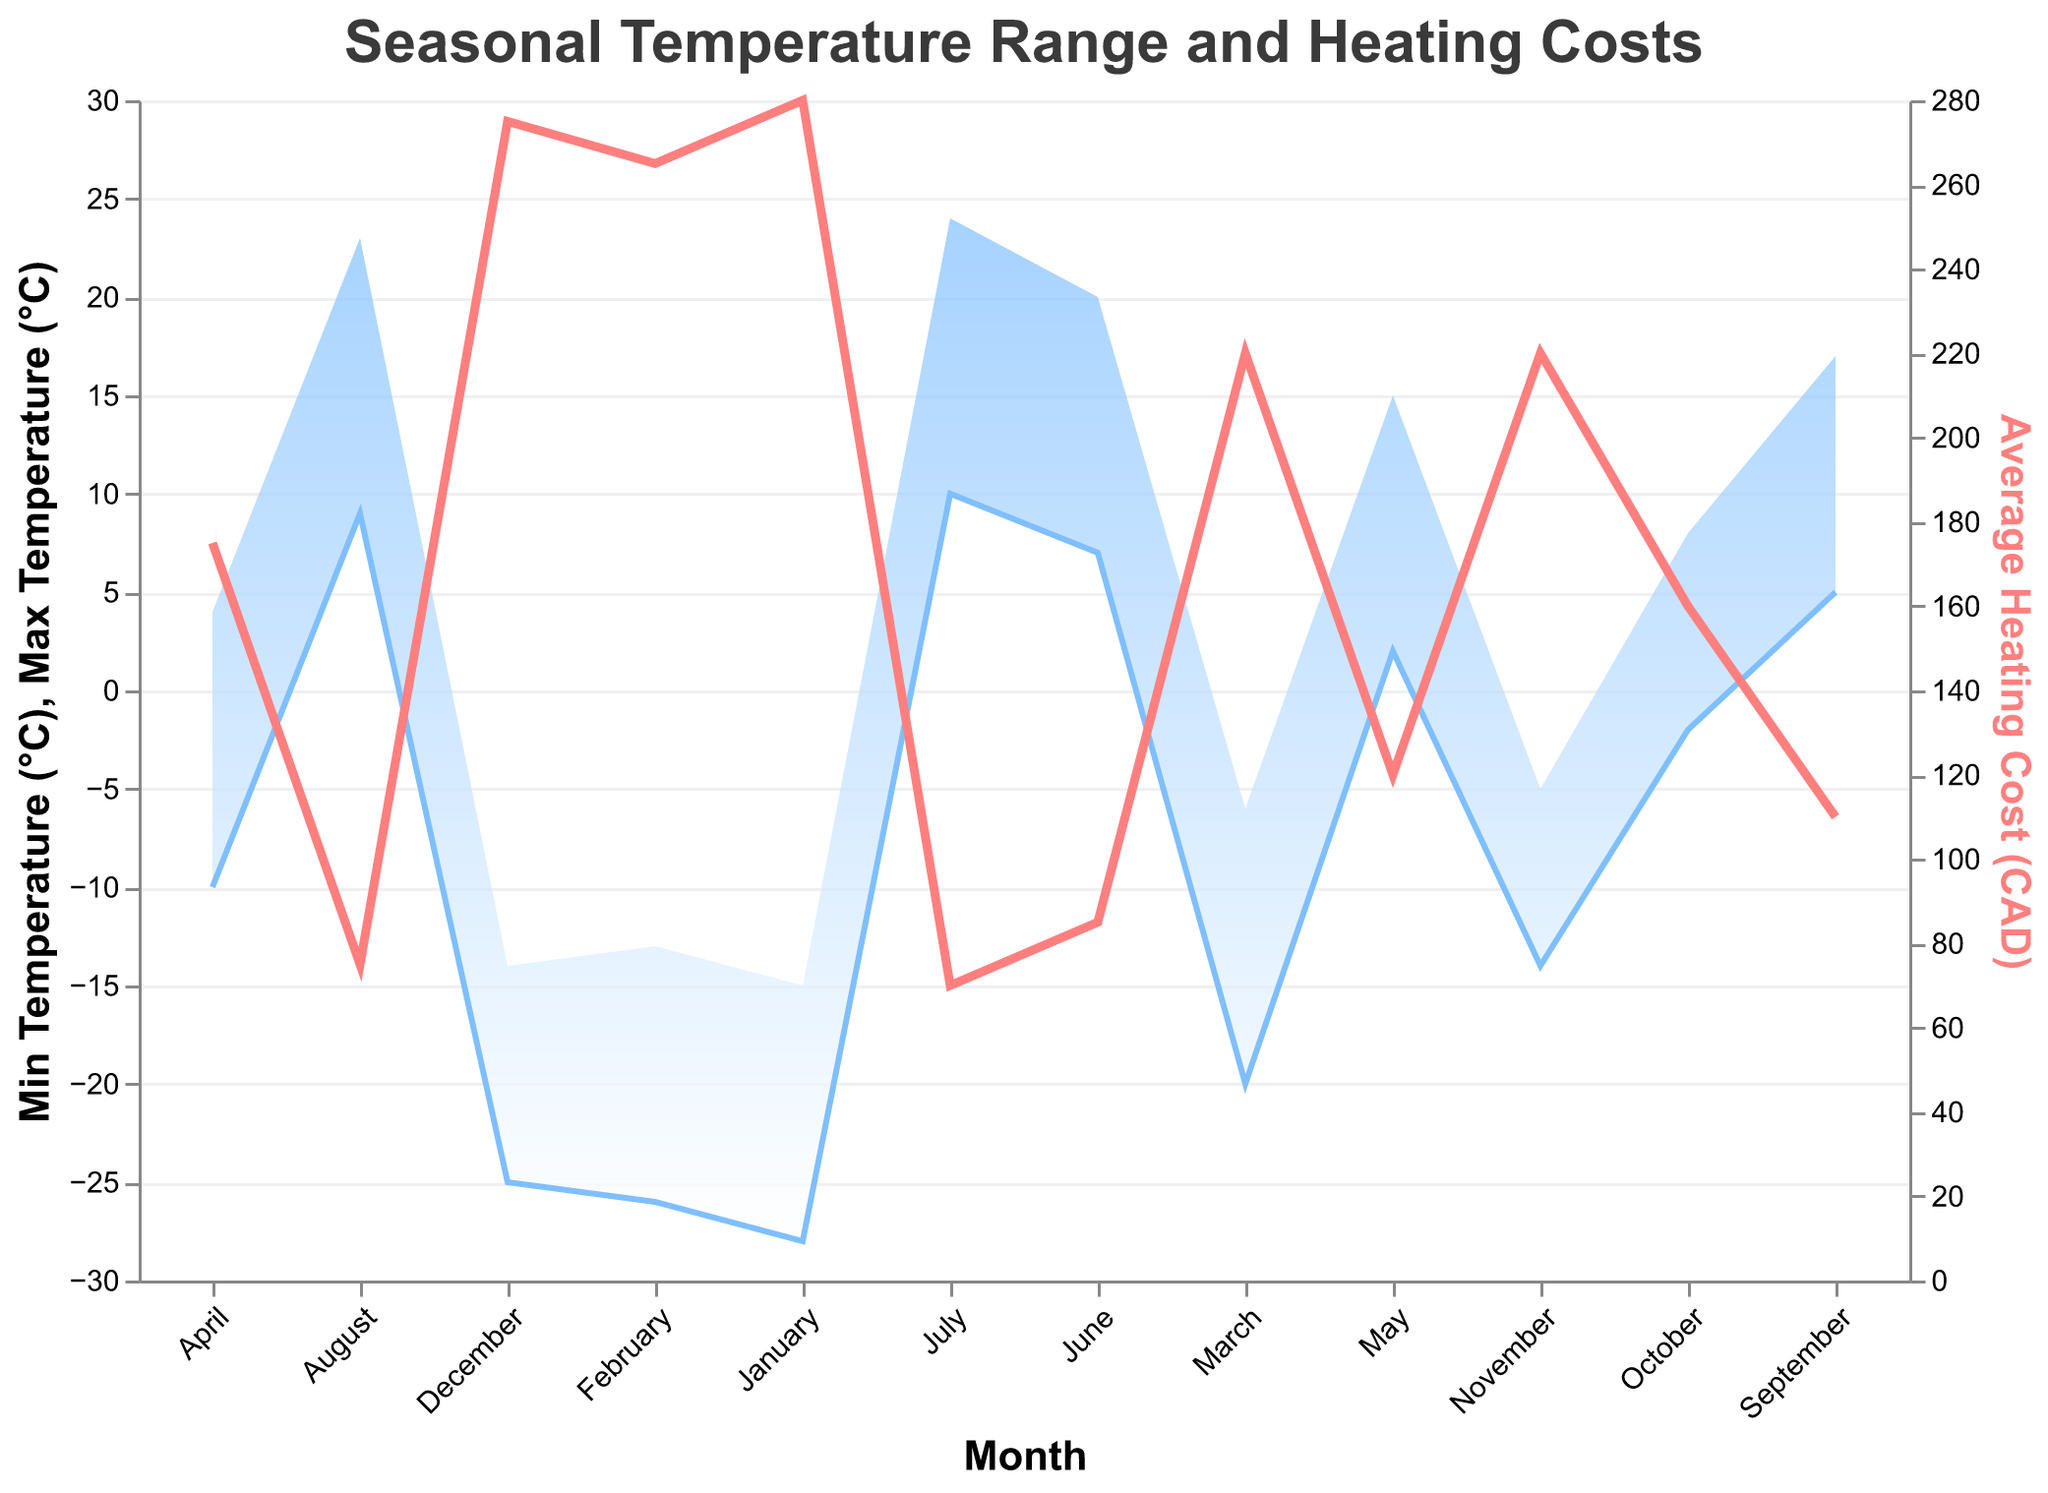what is the title of the figure? The title is located at the top of the figure and provides an overview of the data being presented.
Answer: Seasonal Temperature Range and Heating Costs How many months have an average heating cost above 200 CAD? Count all data points where the average heating cost is above 200 CAD. The months are January, February, March, November, and December, so there are 5 months in total.
Answer: 5 What is the temperature range in January? Find the minimum and maximum temperature for January. The minimum is -28°C and the maximum is -15°C. The range is calculated as Max - Min = -15 - (-28) = 13°C.
Answer: 13°C Which month has the lowest average heating cost? Identify the data point with the lowest "Average Heating Cost (CAD)" value. July has the lowest average heating cost at 70 CAD.
Answer: July How does the trend in heating costs correspond to temperature changes throughout the year? Observing the line and area, heating costs decrease as the temperature increases from January to July and begin to rise again as temperatures drop from September to December. The trend shows an inverse relationship between heating costs and temperatures.
Answer: Inversely related In which month is the temperature range the highest and what is that range? Examine the temperature ranges for each month. July has the highest range with Max Temperature (24°C) - Min Temperature (10°C) = 14°C.
Answer: July, 14°C What is the difference in average heating cost between the coldest month and the warmest month? The coldest month is January with an average heating cost of 280 CAD, and the warmest is July with an average heating cost of 70 CAD. The difference is 280 - 70 = 210 CAD.
Answer: 210 CAD What is the trend in minimum temperature from January to December? Observe the area chart for the minimum temperature line. The trend shows temperatures increasing from January to July and then decreasing from August to December.
Answer: Increases to July, then decreases Which month sees the biggest drop in average heating cost compared to the previous month? Compare the average heating costs month by month. The biggest drop is from April (175 CAD) to May (120 CAD), a reduction of 55 CAD.
Answer: May How does November's temperature range compare to April's? November's temperature range is from -14°C to -5°C, which is 9°C. April's range is from -10°C to 4°C, which is 14°C. April has a larger range.
Answer: April's range is larger 